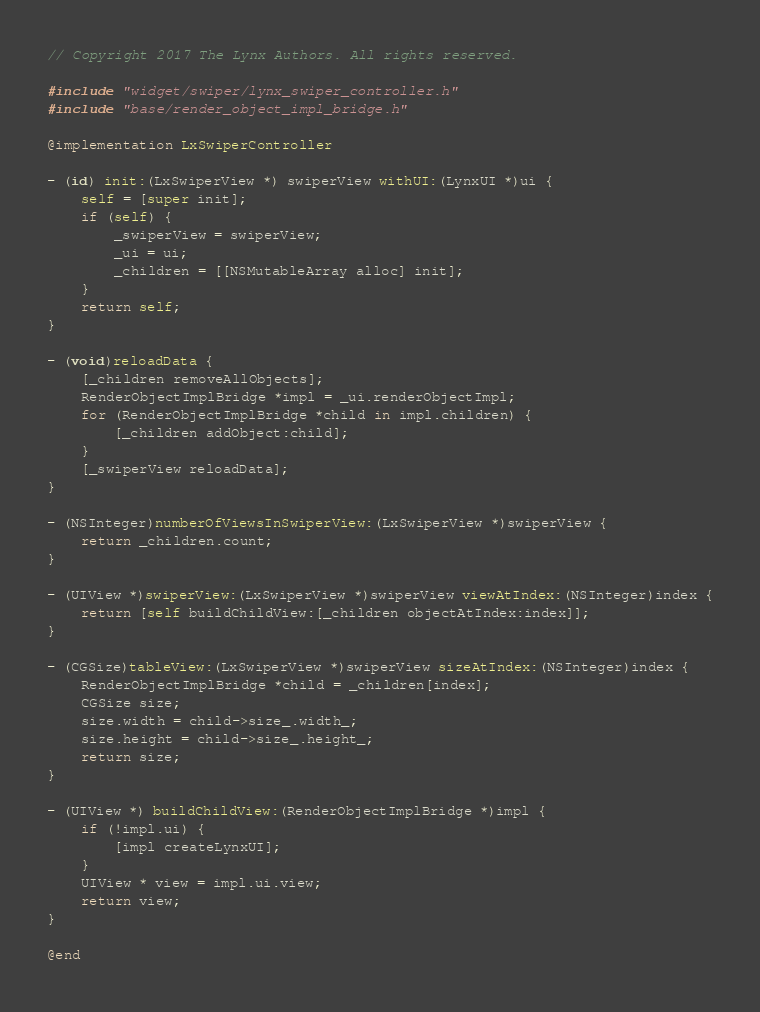Convert code to text. <code><loc_0><loc_0><loc_500><loc_500><_ObjectiveC_>// Copyright 2017 The Lynx Authors. All rights reserved.

#include "widget/swiper/lynx_swiper_controller.h"
#include "base/render_object_impl_bridge.h"

@implementation LxSwiperController

- (id) init:(LxSwiperView *) swiperView withUI:(LynxUI *)ui {
    self = [super init];
    if (self) {
        _swiperView = swiperView;
        _ui = ui;
        _children = [[NSMutableArray alloc] init];
    }
    return self;
}

- (void)reloadData {
    [_children removeAllObjects];
    RenderObjectImplBridge *impl = _ui.renderObjectImpl;
    for (RenderObjectImplBridge *child in impl.children) {
        [_children addObject:child];
    }
    [_swiperView reloadData];
}

- (NSInteger)numberOfViewsInSwiperView:(LxSwiperView *)swiperView {
    return _children.count;
}

- (UIView *)swiperView:(LxSwiperView *)swiperView viewAtIndex:(NSInteger)index {
    return [self buildChildView:[_children objectAtIndex:index]];
}

- (CGSize)tableView:(LxSwiperView *)swiperView sizeAtIndex:(NSInteger)index {
    RenderObjectImplBridge *child = _children[index];
    CGSize size;
    size.width = child->size_.width_;
    size.height = child->size_.height_;
    return size;
}

- (UIView *) buildChildView:(RenderObjectImplBridge *)impl {
    if (!impl.ui) {
        [impl createLynxUI];
    }
    UIView * view = impl.ui.view;
    return view;
}
 
@end
</code> 